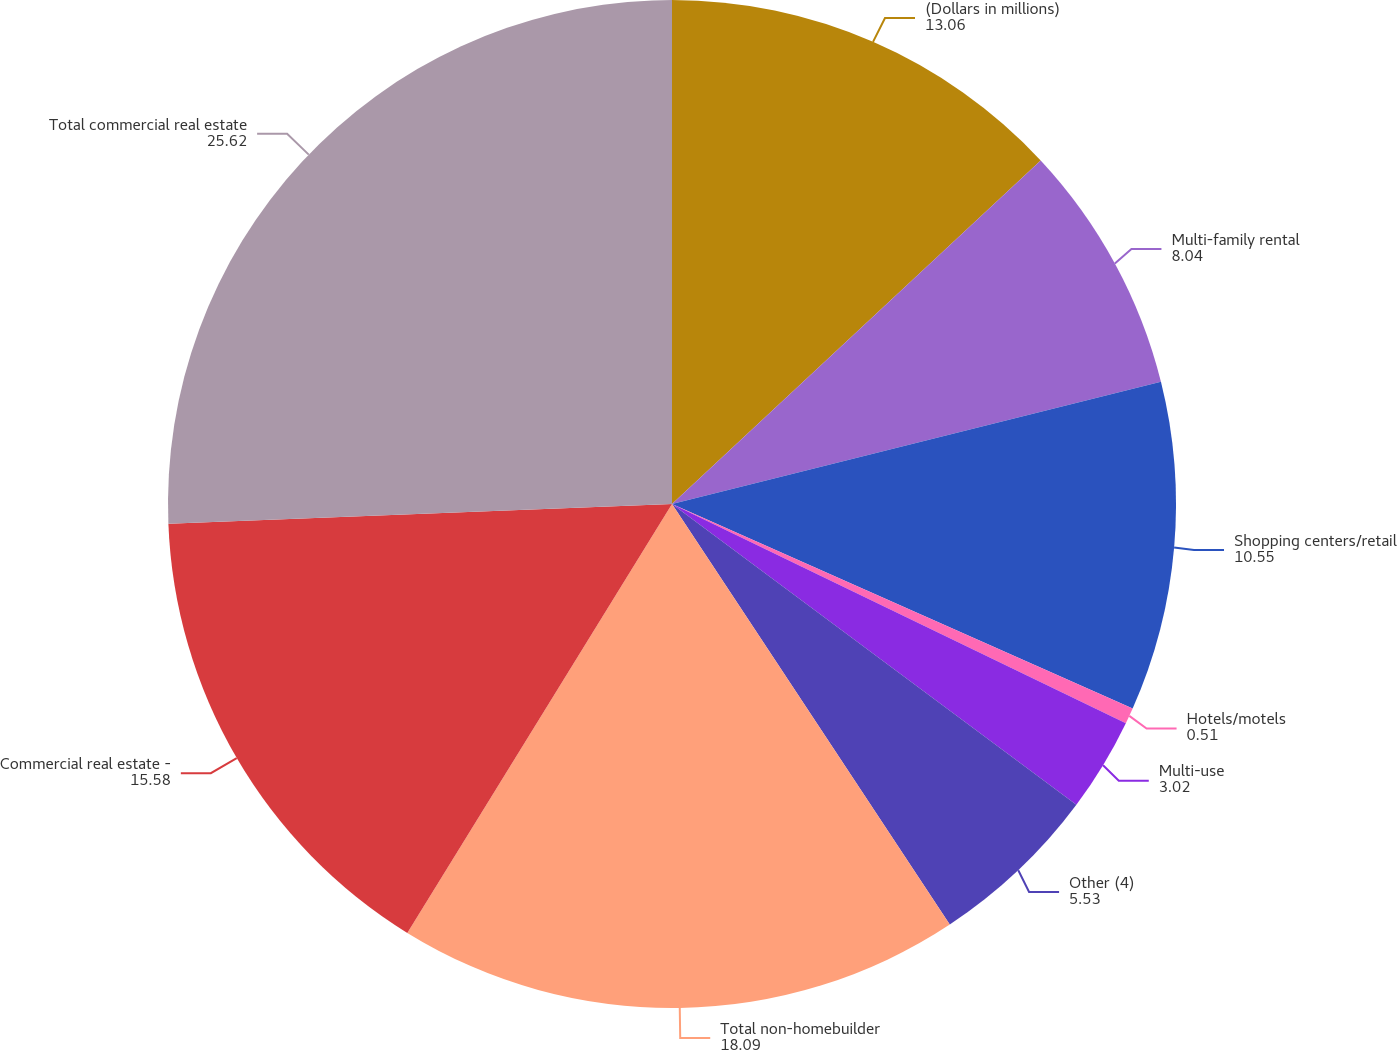<chart> <loc_0><loc_0><loc_500><loc_500><pie_chart><fcel>(Dollars in millions)<fcel>Multi-family rental<fcel>Shopping centers/retail<fcel>Hotels/motels<fcel>Multi-use<fcel>Other (4)<fcel>Total non-homebuilder<fcel>Commercial real estate -<fcel>Total commercial real estate<nl><fcel>13.06%<fcel>8.04%<fcel>10.55%<fcel>0.51%<fcel>3.02%<fcel>5.53%<fcel>18.09%<fcel>15.58%<fcel>25.62%<nl></chart> 